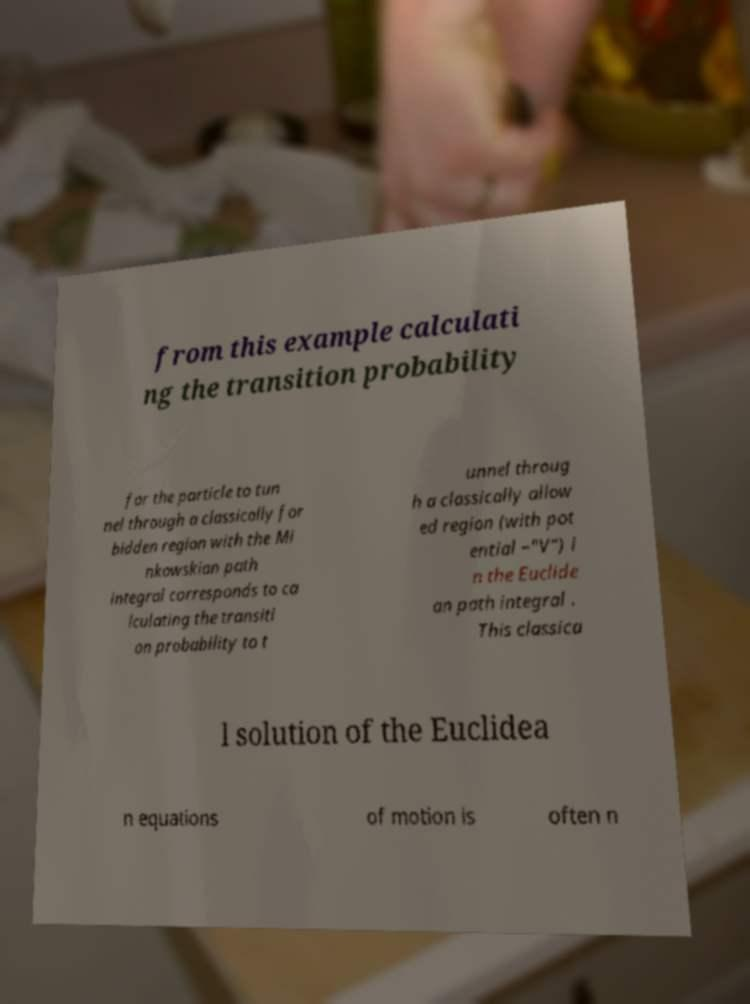Could you assist in decoding the text presented in this image and type it out clearly? from this example calculati ng the transition probability for the particle to tun nel through a classically for bidden region with the Mi nkowskian path integral corresponds to ca lculating the transiti on probability to t unnel throug h a classically allow ed region (with pot ential −"V") i n the Euclide an path integral . This classica l solution of the Euclidea n equations of motion is often n 